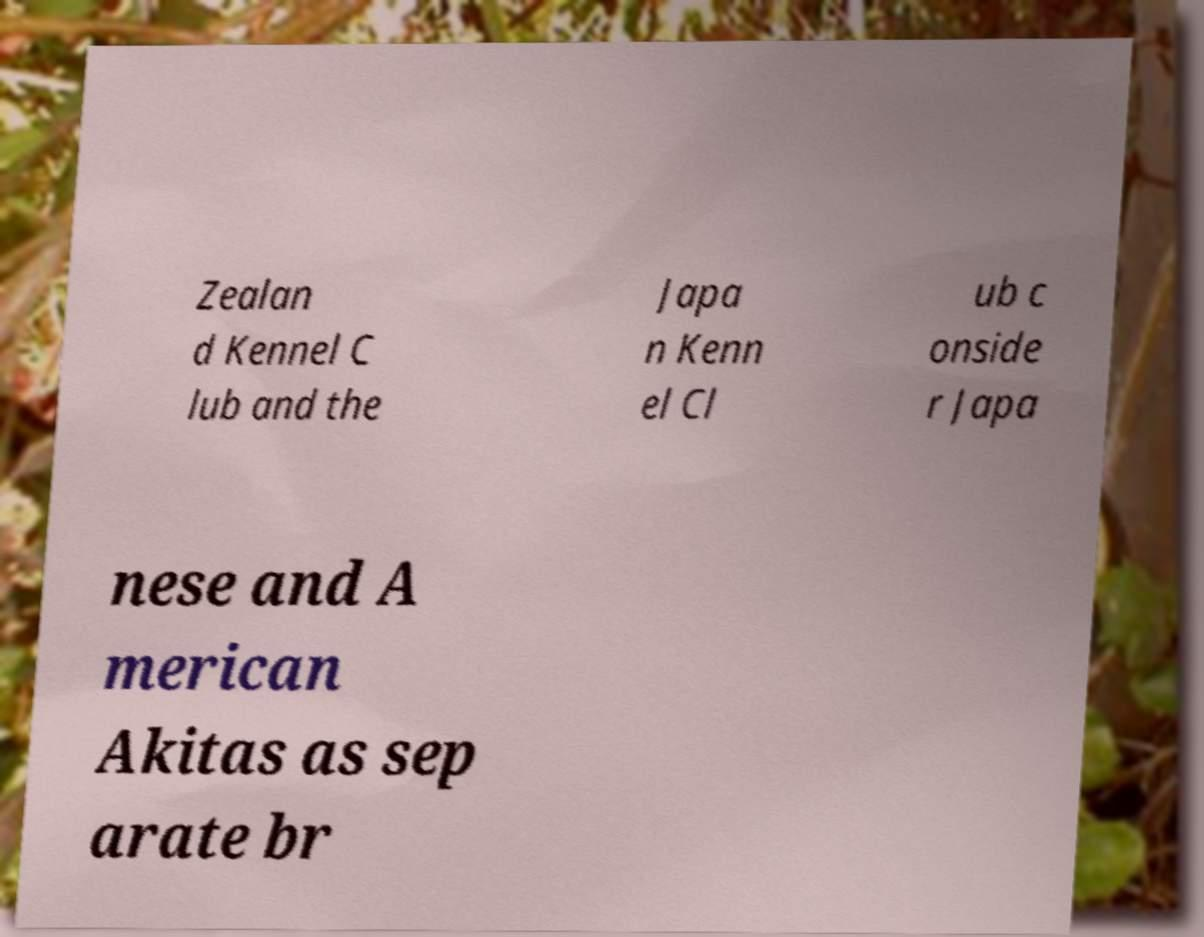What messages or text are displayed in this image? I need them in a readable, typed format. Zealan d Kennel C lub and the Japa n Kenn el Cl ub c onside r Japa nese and A merican Akitas as sep arate br 